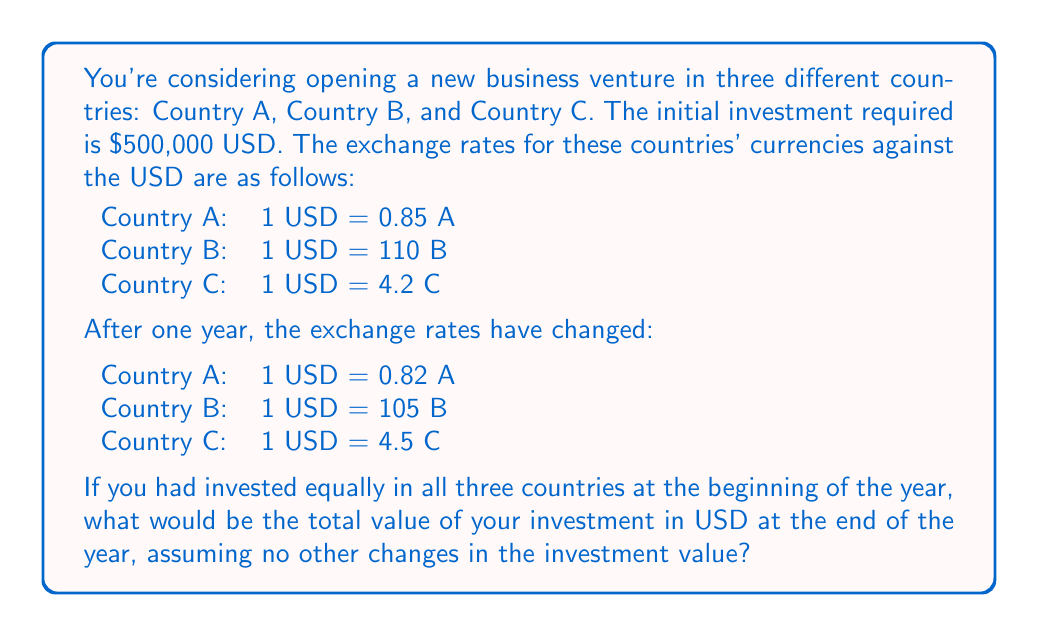Can you answer this question? Let's approach this step-by-step:

1) First, we need to calculate how much of each country's currency we would have received for our initial investment.

   Total investment = $500,000 USD
   Investment per country = $500,000 / 3 = $166,666.67 USD

   Country A: $166,666.67 * 0.85 = 141,666.67 A
   Country B: $166,666.67 * 110 = 18,333,333.33 B
   Country C: $166,666.67 * 4.2 = 700,000 C

2) Now, we need to convert these amounts back to USD using the new exchange rates:

   Country A: 141,666.67 A / 0.82 = $172,764.23 USD
   Country B: 18,333,333.33 B / 105 = $174,603.17 USD
   Country C: 700,000 C / 4.5 = $155,555.56 USD

3) Finally, we sum up these amounts:

   Total value = $172,764.23 + $174,603.17 + $155,555.56 = $502,922.96 USD

The mathematical representation of this process can be expressed as:

$$\sum_{i=1}^{3} \frac{(\frac{500000}{3} \cdot R_i)}{R'_i}$$

Where $R_i$ is the initial exchange rate for country $i$ and $R'_i$ is the final exchange rate for country $i$.
Answer: $502,922.96 